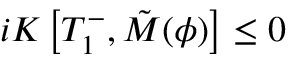<formula> <loc_0><loc_0><loc_500><loc_500>i K \left [ T _ { 1 } ^ { - } , \tilde { M } ( { \phi } ) \right ] \leq 0</formula> 